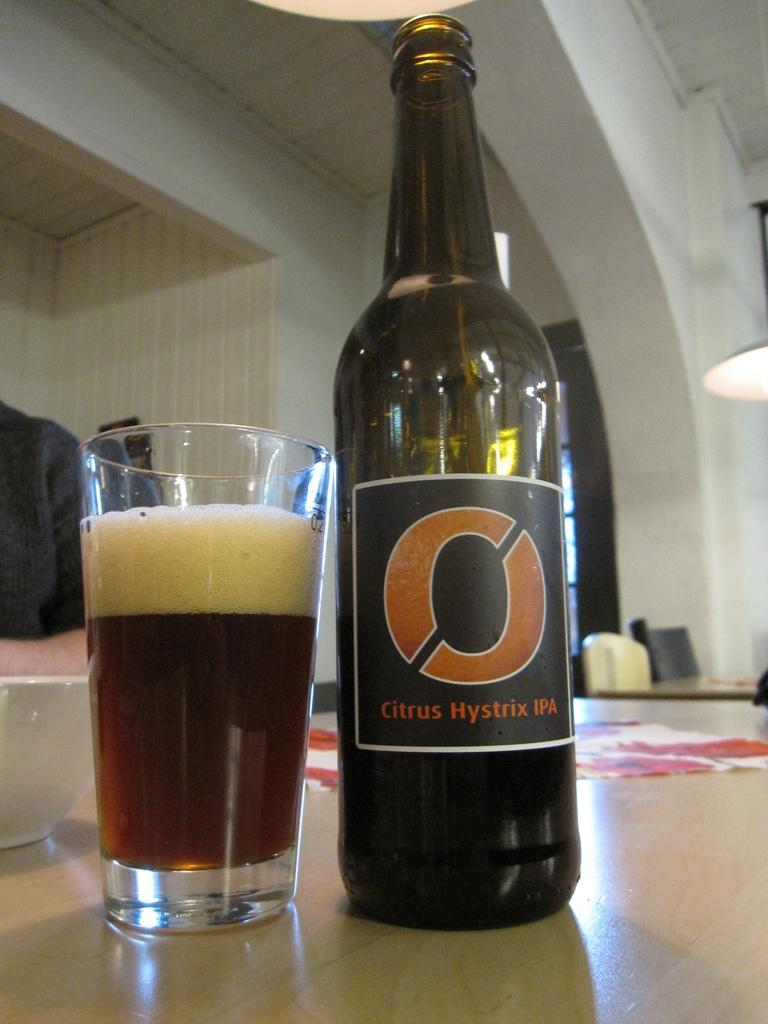Provide a one-sentence caption for the provided image. A bottle of citrus hystrix IPA has a big O on the label. 